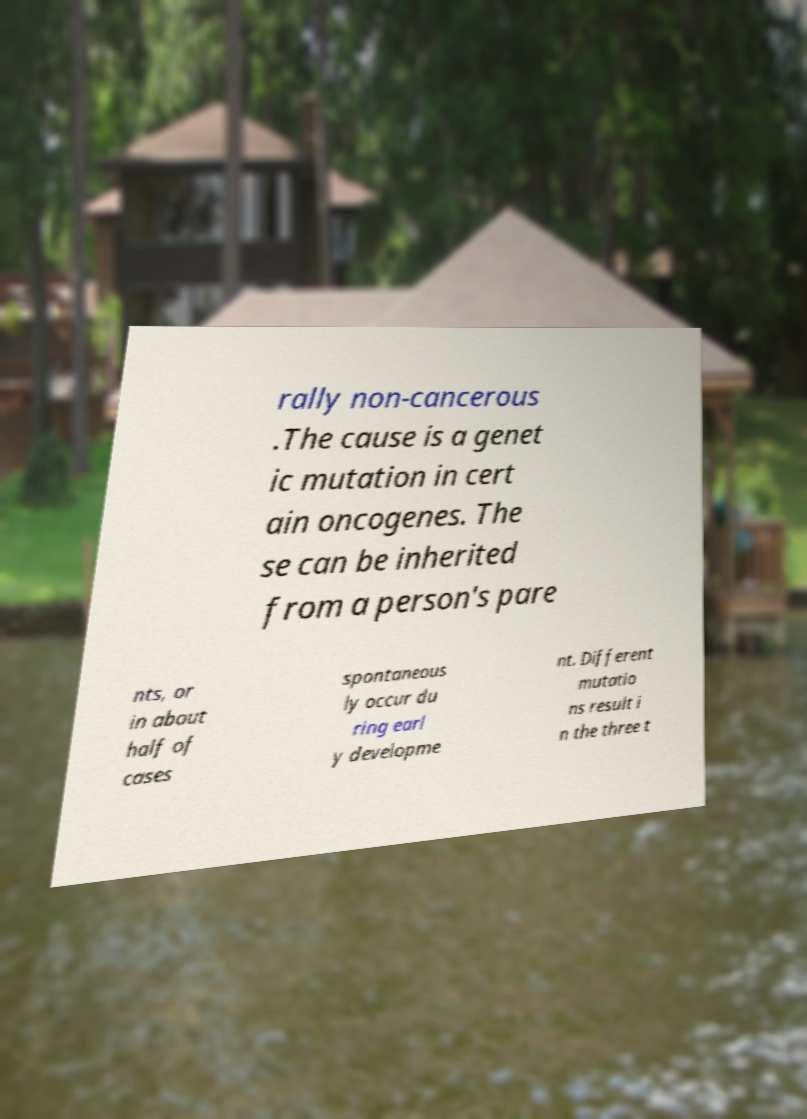For documentation purposes, I need the text within this image transcribed. Could you provide that? rally non-cancerous .The cause is a genet ic mutation in cert ain oncogenes. The se can be inherited from a person's pare nts, or in about half of cases spontaneous ly occur du ring earl y developme nt. Different mutatio ns result i n the three t 